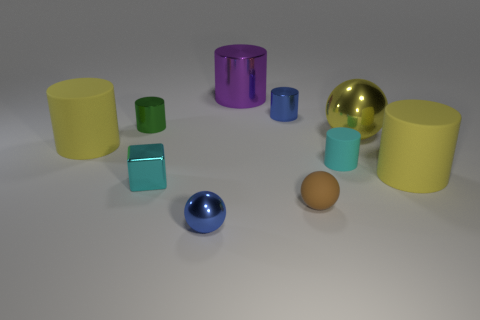Can you describe the different colors and materials present among the objects in the image? Certainly. The image displays a variety of objects with different colors and materials. There are objects in yellow, green, cyan, blue, purple, and a golden hue. Material-wise, the objects seem to have matte, shiny metallic, and possibly plastic finishes.  Which object stands out the most to you and why? The golden, shiny metallic ball stands out the most due to its reflective surface and striking color that contrasts with the muted tones of the other objects. 